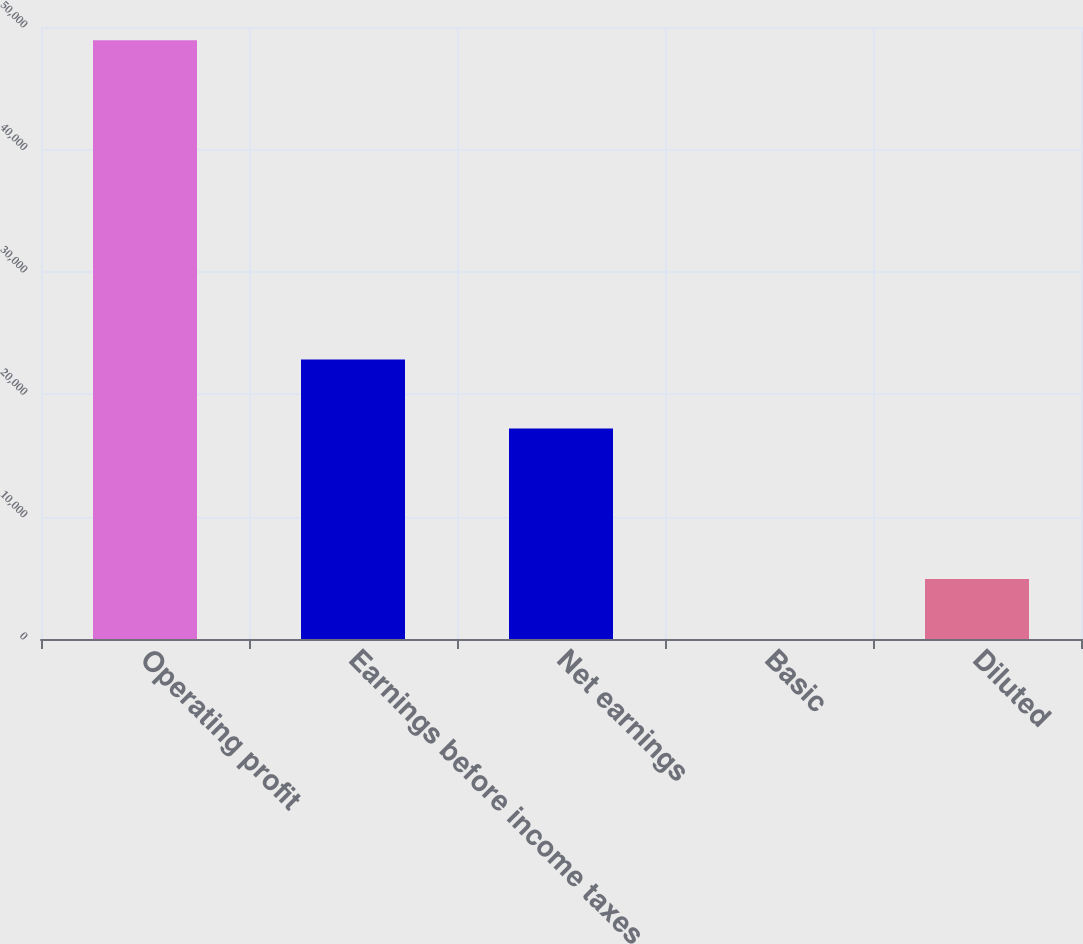Convert chart to OTSL. <chart><loc_0><loc_0><loc_500><loc_500><bar_chart><fcel>Operating profit<fcel>Earnings before income taxes<fcel>Net earnings<fcel>Basic<fcel>Diluted<nl><fcel>48923<fcel>22838<fcel>17196<fcel>0.12<fcel>4892.41<nl></chart> 